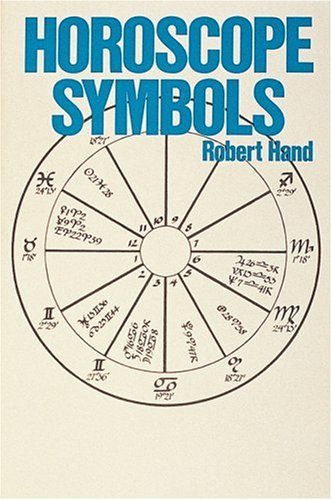What type of book is this? This book falls under the category of astrology, which often intersects with topics of spirituality and metaphysical studies. It provides detailed interpretations of horoscope symbols used in astrological charts. 